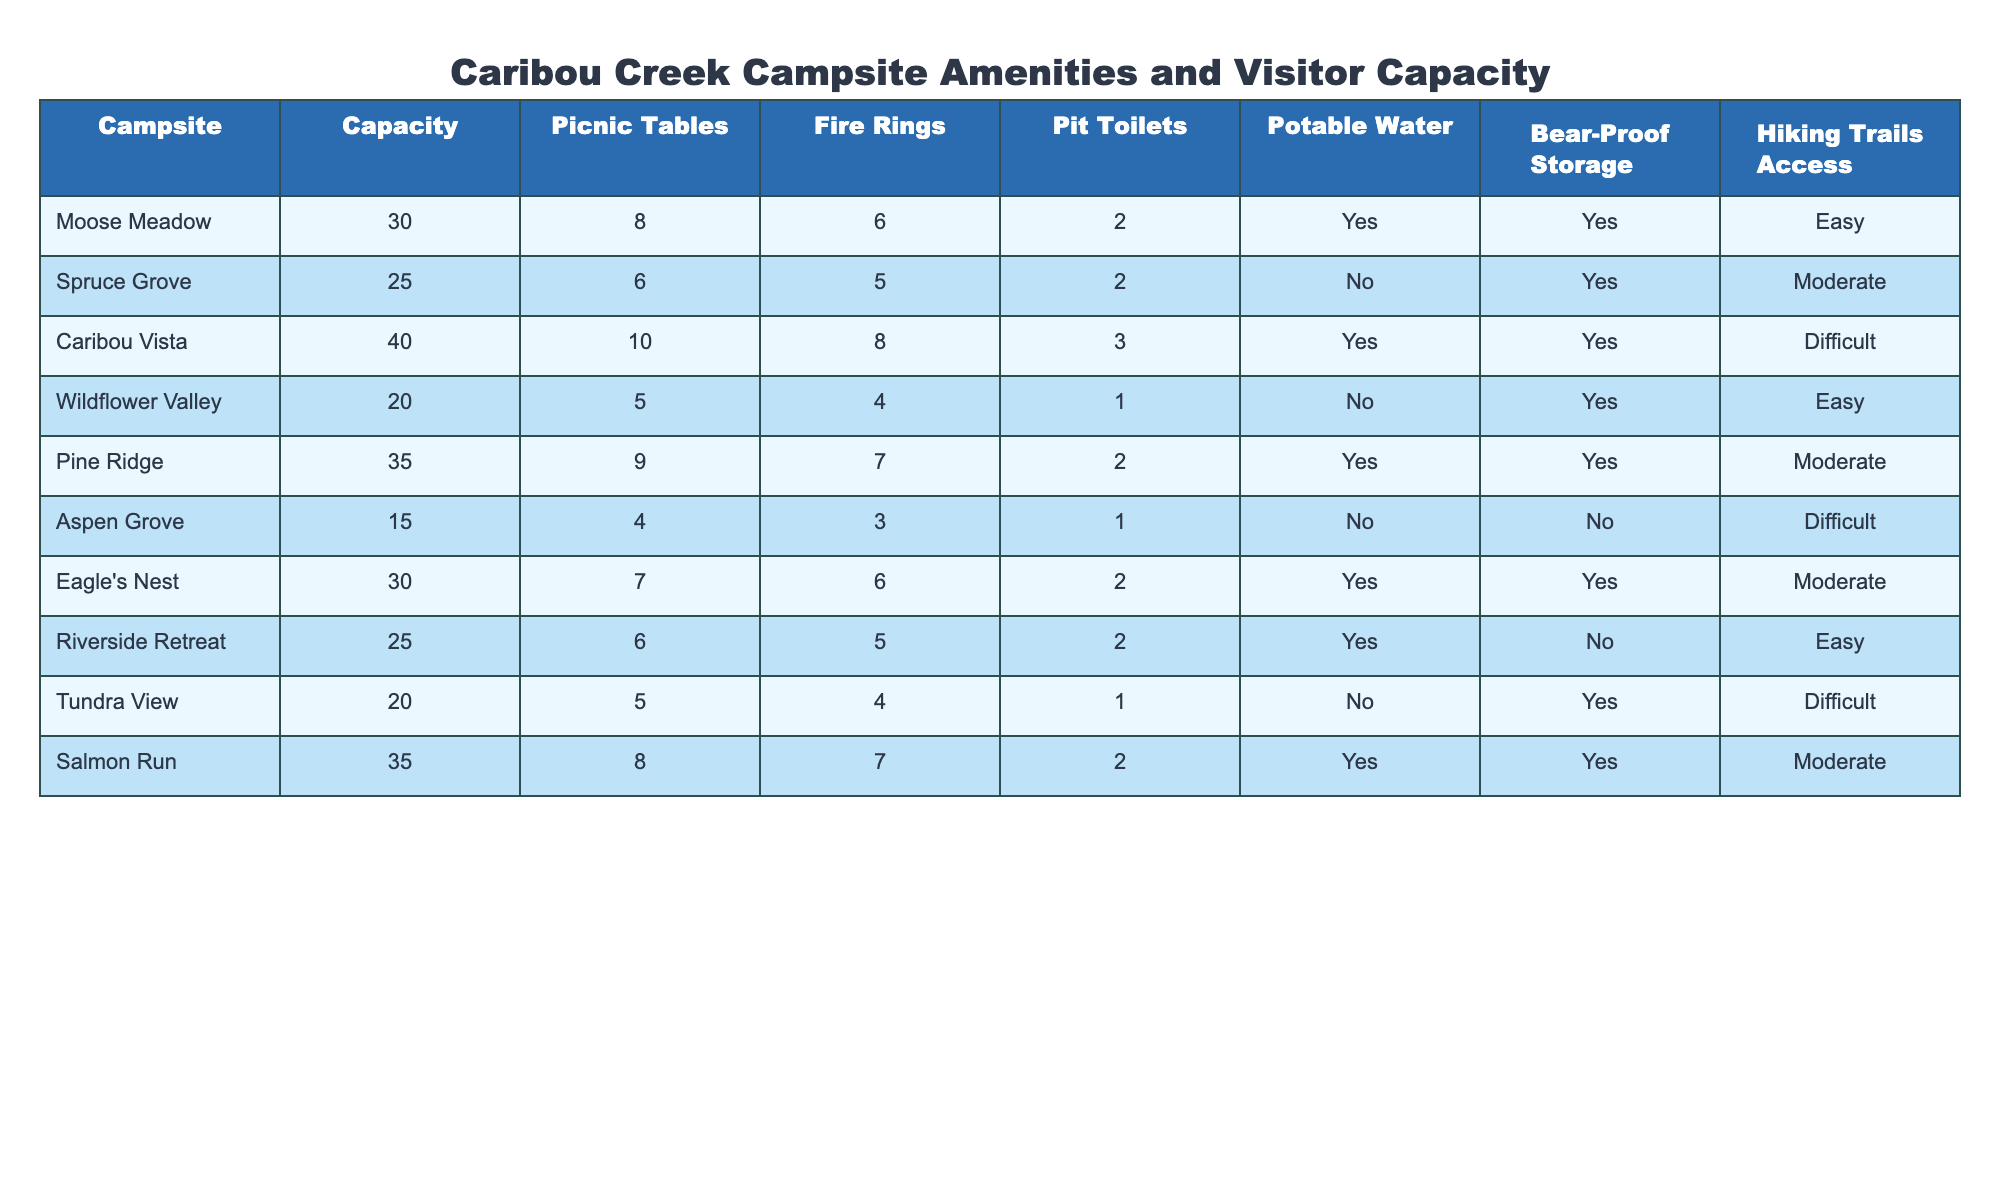What is the visitor capacity of Caribou Vista? The visitor capacity for Caribou Vista is explicitly listed in the table under the 'Capacity' column, which shows a capacity of 40.
Answer: 40 How many picnic tables does the Wildflower Valley campsite have? The number of picnic tables for Wildflower Valley can be found directly in the table under the 'Picnic Tables' column, showing that it has 5.
Answer: 5 Which campsite has the highest number of fire rings? By comparing the values in the 'Fire Rings' column, Caribou Vista has the highest number with 8 fire rings.
Answer: Caribou Vista How many campsites provide potable water? To find the number of campsites with potable water, I check the 'Potable Water' column for the entries marked 'Yes'. There are 5 campsites that offer potable water.
Answer: 5 What is the average capacity of all the campsites listed? First, I sum up all capacities: (30 + 25 + 40 + 20 + 35 + 15 + 30 + 25 + 20 + 35) = 305. There are 10 campsites, so the average capacity is 305/10 = 30.5.
Answer: 30.5 Is there a campsite with both bear-proof storage and accessible hiking trails? I check the 'Bear-Proof Storage' column for 'Yes' and the 'Hiking Trails Access' column for 'Easy' or 'Moderate'. Moose Meadow, Pine Ridge, Eagle's Nest, and Salmon Run meet these criteria.
Answer: Yes Which campsite has the lowest visitor capacity and no bear-proof storage? Aspen Grove has the lowest capacity at 15 and does not provide bear-proof storage, according to the 'Capacity' and 'Bear-Proof Storage' columns.
Answer: Aspen Grove Calculate the total number of fire rings across all campsites. I sum the fire rings from each campsite: (6 + 5 + 8 + 4 + 7 + 3 + 6 + 5 + 4 + 7) = 55. So, the total number of fire rings is 55.
Answer: 55 How many campsites have both moderate hiking access and fire rings greater than 5? The campsites with moderate hiking access are Spruce Grove, Pine Ridge, Eagle's Nest, and Salmon Run. Among these, only Pine Ridge (7 fire rings) and Salmon Run (7 fire rings) have fire rings greater than 5. Thus, there are 2 such campsites.
Answer: 2 What percentage of campsites lack pit toilets? There are 3 campsites without pit toilets: Wildflower Valley, Aspen Grove, and Tundra View out of 10 total campsites. Thus, the percentage is (3/10) * 100 = 30%.
Answer: 30% 